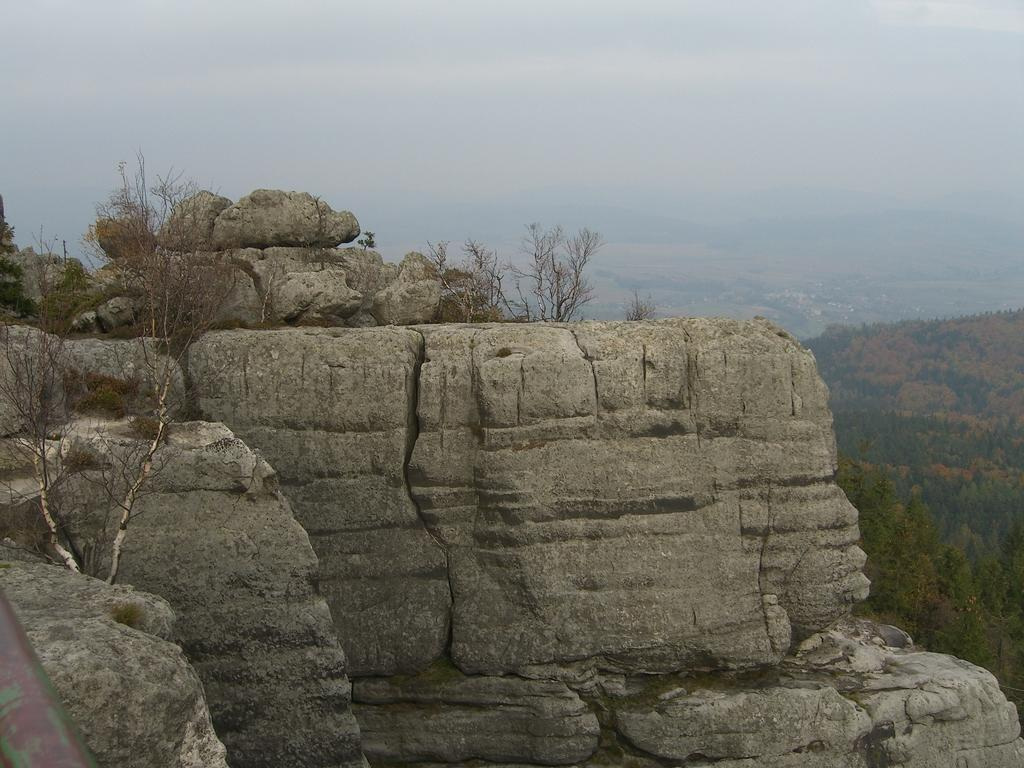What type of landscape can be seen in the image? There are hills in the image. What other natural elements are present in the image? There are trees in the image. What is visible in the background of the image? The sky is visible in the image. How many matches are being used to light the trees in the image? There are no matches or any indication of fire in the image; it features hills, trees, and the sky. 